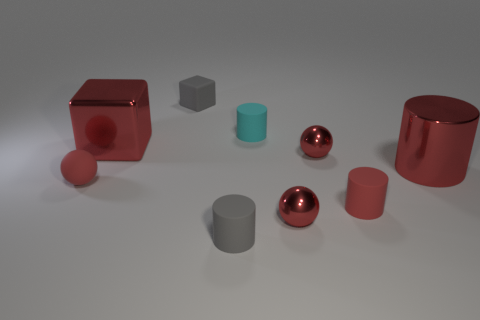Subtract all red shiny cylinders. How many cylinders are left? 3 Subtract all gray cubes. How many cubes are left? 1 Subtract all cubes. How many objects are left? 7 Subtract all cyan blocks. How many brown cylinders are left? 0 Add 2 tiny cyan rubber objects. How many tiny cyan rubber objects are left? 3 Add 7 cyan rubber cylinders. How many cyan rubber cylinders exist? 8 Subtract 0 green balls. How many objects are left? 9 Subtract 2 balls. How many balls are left? 1 Subtract all gray blocks. Subtract all blue cylinders. How many blocks are left? 1 Subtract all shiny spheres. Subtract all metal spheres. How many objects are left? 5 